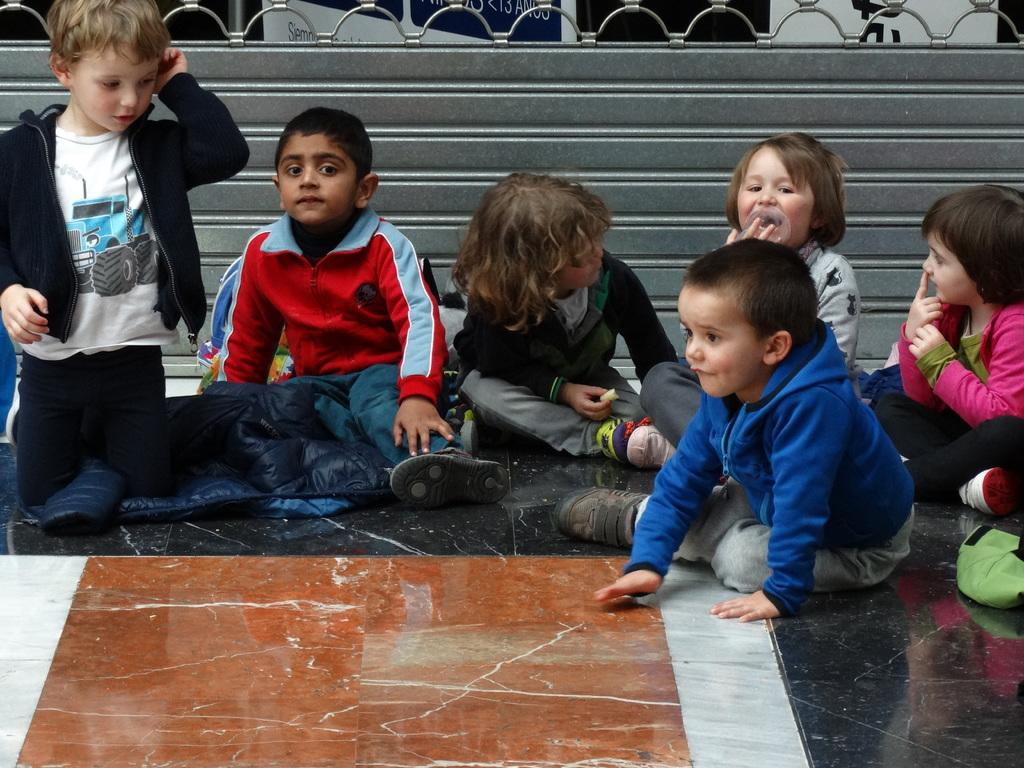How many children are sitting in the image? There are six children sitting in the image. What are the children wearing? The children are wearing clothes and shoes. What type of flooring is visible in the image? There is a marble floor visible in the image. What can be seen in the background of the image? There is a fence in the image. Can you see any veins in the children's arms in the image? There is no indication of visible veins in the children's arms in the image. Are the children laughing in the image? The image does not show the children's facial expressions, so it cannot be determined if they are laughing. 